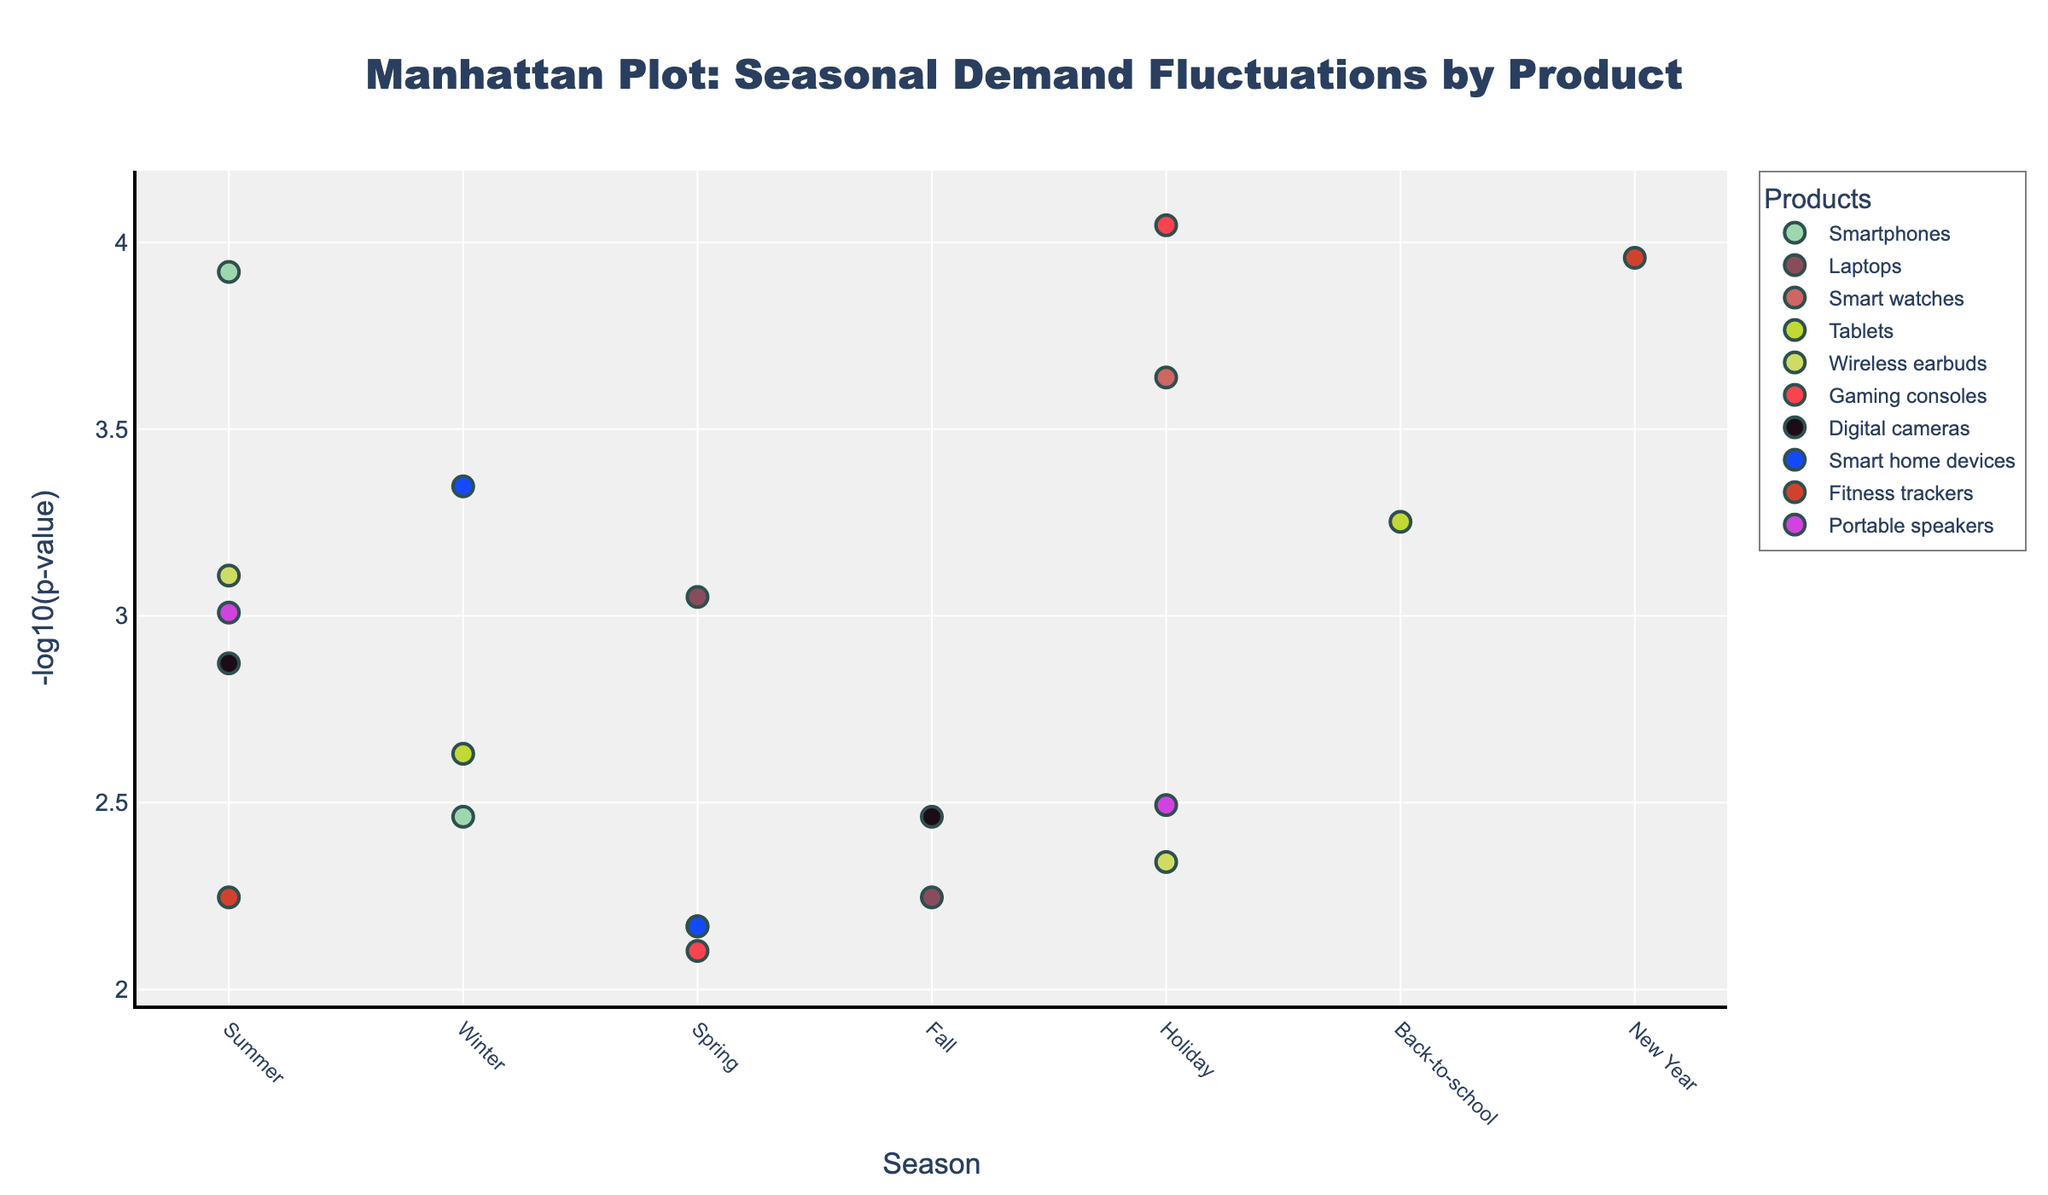What is the title of the plot? The title is usually displayed at the top of the plot. This plot's title is in a large font and centered.
Answer: Manhattan Plot: Seasonal Demand Fluctuations by Product What does the y-axis represent in the plot? By looking at the y-axis title, it shows that the y-axis represents `-log10(p-value)`, translating the p-values to a logarithmic scale to showcase the significance of seasonal demand fluctuations visually.
Answer: -log10(p-value) Which product shows the highest significance in seasonal demand fluctuations during the Holiday season? To find this, we need to look for the product with the highest `-log10(p-value)` value in the Holiday season. From the graph, it appears that Gaming consoles have the highest value in this season.
Answer: Gaming consoles How many data points are displayed for the Summer season across all products? Observe the 'Summer' tick mark on the x-axis and count all the markers stacked under it. There are 4 data points in the Summer season.
Answer: 4 Which season shows the lowest significance (highest p-value) for the product 'Fitness trackers'? Find the product 'Fitness trackers' and compare the `-log10(p-value)` values for the seasons New Year and Summer. The Summer season has a higher p-value because the `-log10(p-value)` is lower.
Answer: Summer What are the top two products with the highest significance levels during the Spring season? Look at the Spring season and identify markers with the highest `-log10(p-value)` values. 'Laptops' and 'Smart home devices' appear to have the highest significance levels.
Answer: Laptops and Smart home devices Compare the significance levels of 'Tablets' between the Winter and Back-to-school seasons. Which one is more significant? Check the positions of 'Tablets' in both the Winter and Back-to-school seasons. The Back-to-school season has a higher `-log10(p-value)`, indicating greater significance.
Answer: Back-to-school What is the color of the markers for 'Wireless earbuds' in the plot? Each product has a unique color assigned to it. Locate 'Wireless earbuds' in the legend or directly in the plot to determine the color assigned to its markers.
Answer: Varies (exact color defined uniquely for 'Wireless earbuds' in the plot) Which product has shown significant demand fluctuations in the New Year season? The New Year season is among the x-axis ticks. The marker in this season corresponds to 'Fitness trackers', which has a low p-value indicated by a high `-log10(p-value)` value.
Answer: Fitness trackers Which product among 'Smart home devices', 'Laptops', and 'Digital cameras' shows the highest seasonal demand fluctuations during the Winter season? Compare the `-log10(p-value)` values for 'Smart home devices', 'Laptops', and 'Digital cameras' specifically for the Winter season. 'Smart home devices' has the highest value, indicating the most significant demand fluctuations.
Answer: Smart home devices 